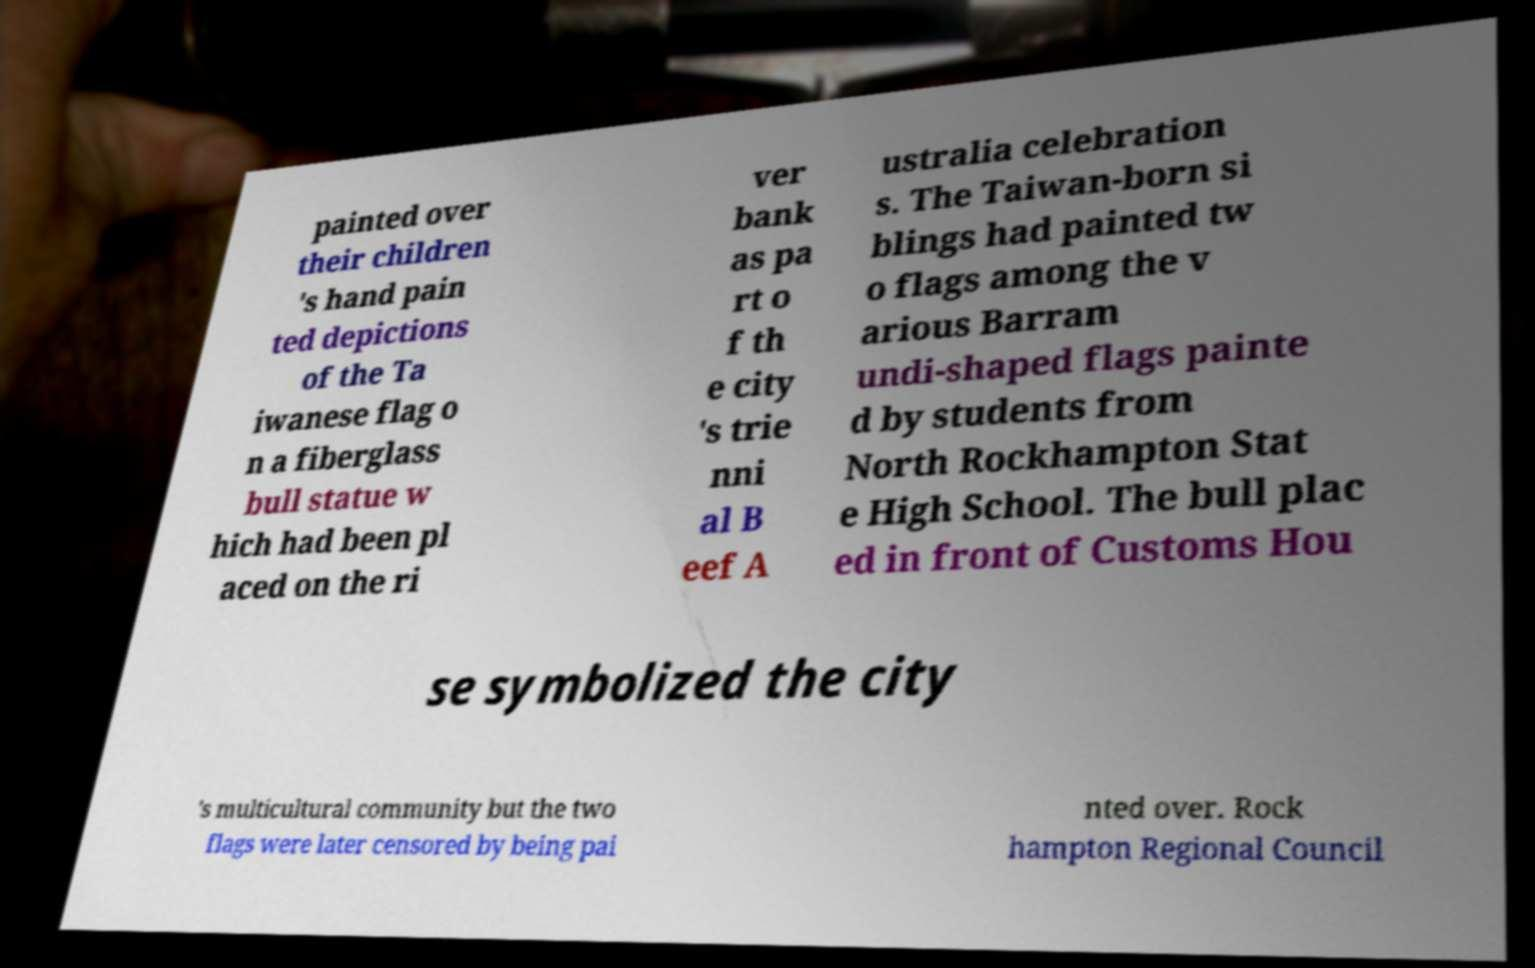Please read and relay the text visible in this image. What does it say? painted over their children 's hand pain ted depictions of the Ta iwanese flag o n a fiberglass bull statue w hich had been pl aced on the ri ver bank as pa rt o f th e city 's trie nni al B eef A ustralia celebration s. The Taiwan-born si blings had painted tw o flags among the v arious Barram undi-shaped flags painte d by students from North Rockhampton Stat e High School. The bull plac ed in front of Customs Hou se symbolized the city 's multicultural community but the two flags were later censored by being pai nted over. Rock hampton Regional Council 